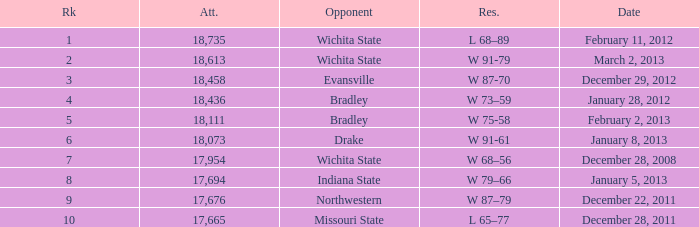What's the rank when attendance was less than 18,073 and having Northwestern as an opponent? 9.0. 